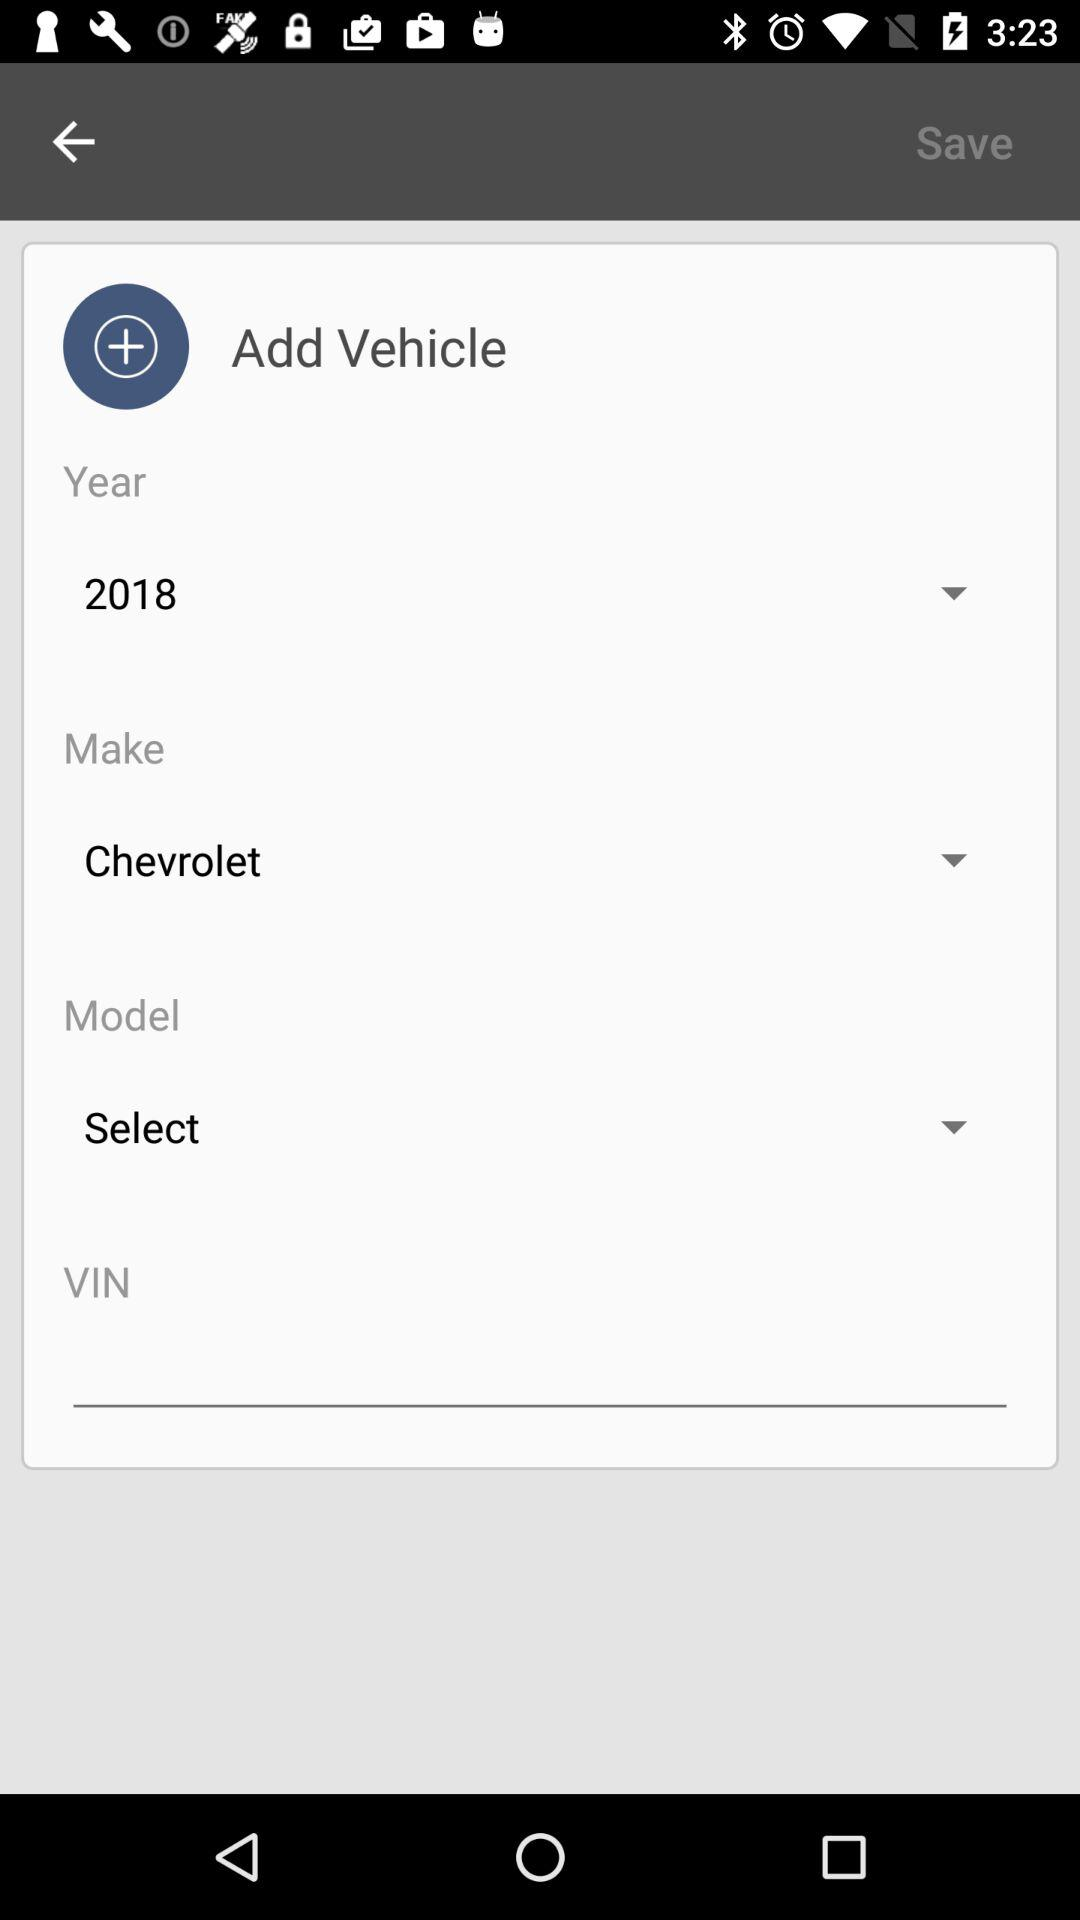When was the "Chevrolet" vehicle made? The "Chevrolet" vehicle was made in 2018. 